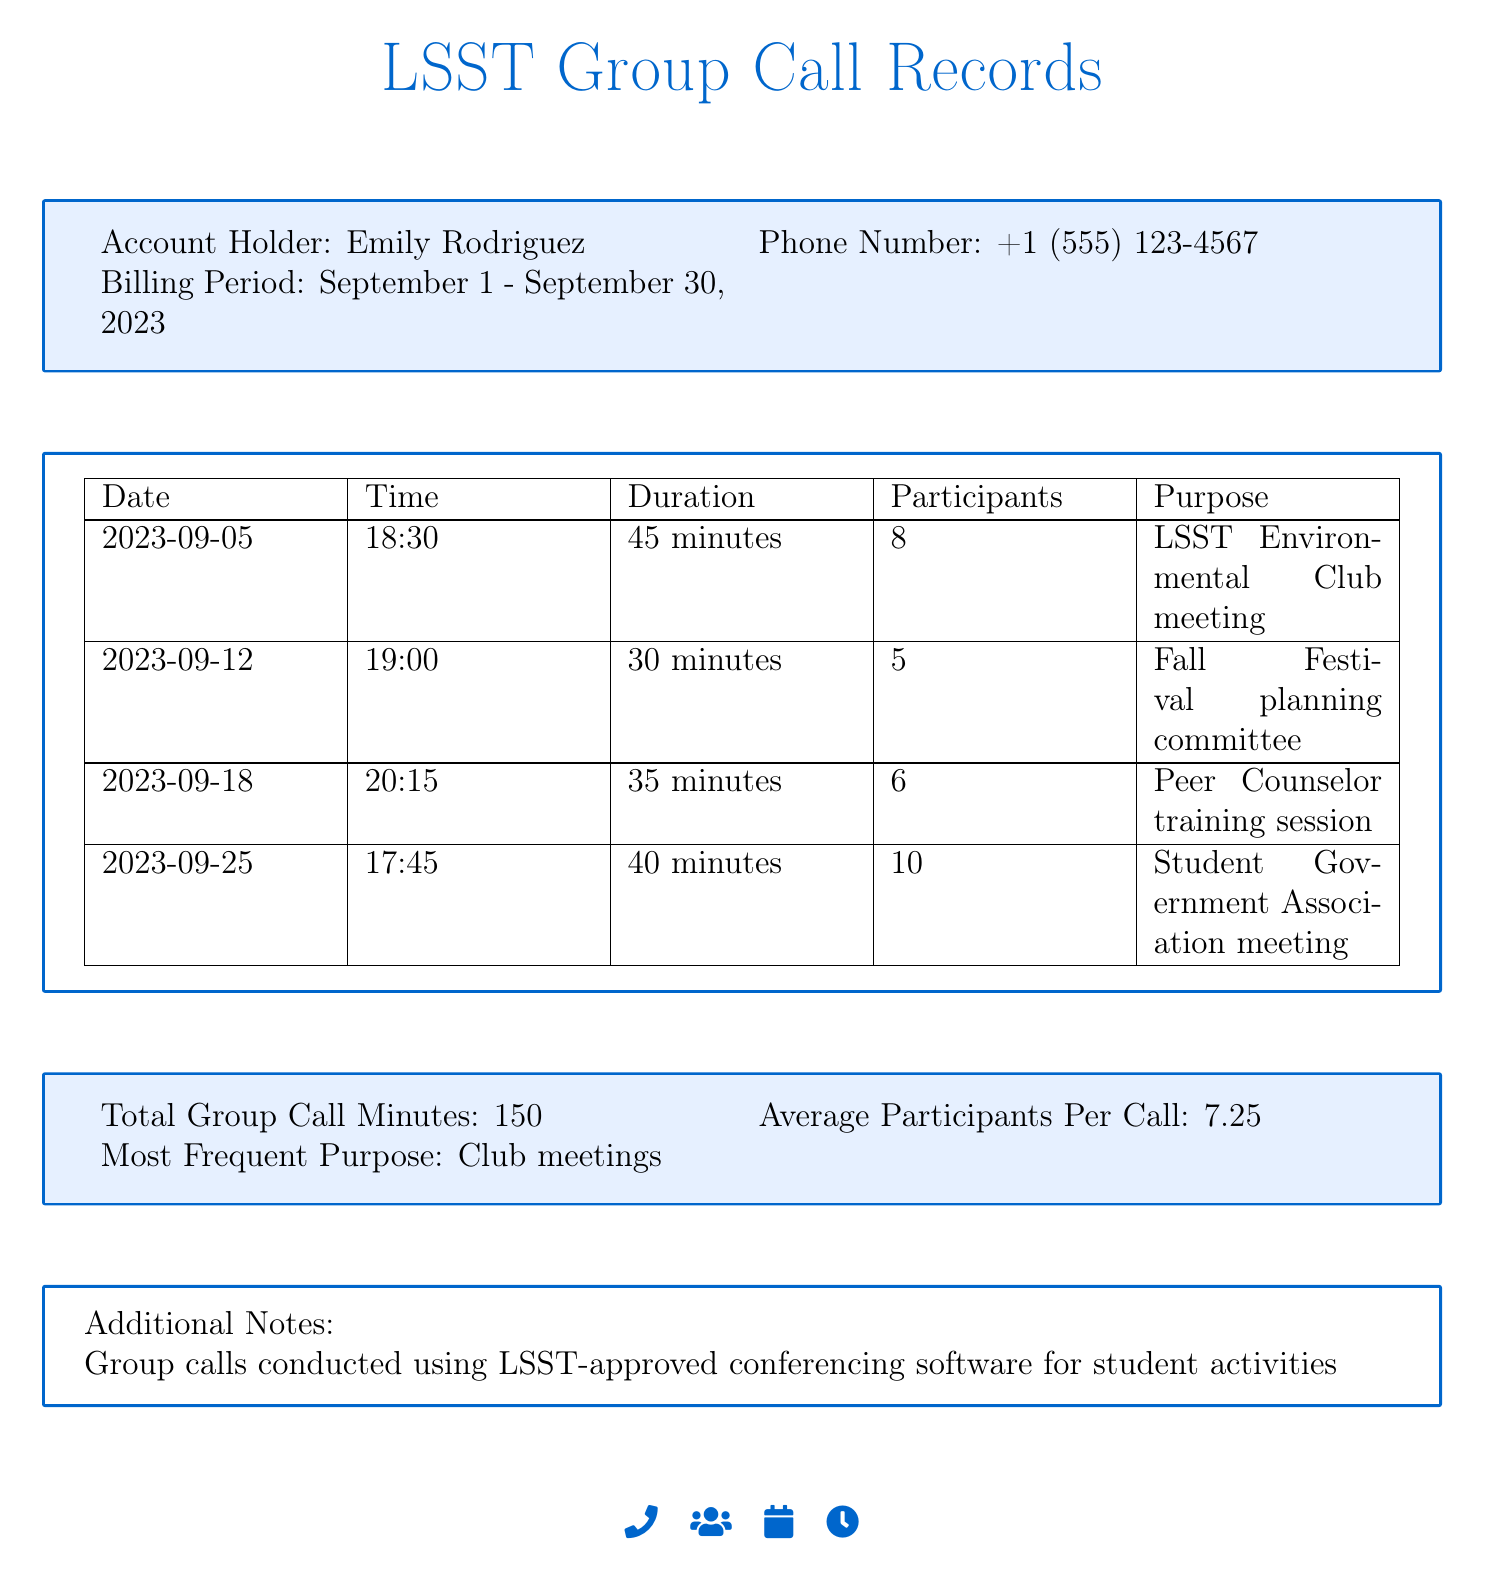what is the account holder's name? The account holder's name is mentioned at the top of the document.
Answer: Emily Rodriguez what is the phone number? The phone number is provided alongside the account holder's name in the document.
Answer: +1 (555) 123-4567 what is the billing period? The billing period is specified in the document for the group call records.
Answer: September 1 - September 30, 2023 how many minutes were used for group calls? The total group call minutes are summarized in the main section of the document.
Answer: 150 what was the most frequent purpose of the calls? This information is detailed at the end of the group call records section.
Answer: Club meetings how many participants were involved in the LSST Environmental Club meeting? The number of participants is listed next to the date and time of the specific call.
Answer: 8 on which date was the Peer Counselor training session held? The date is provided in the table that outlines the call records.
Answer: 2023-09-18 how many minutes did the Fall Festival planning committee call last? The call duration for the specific purpose is listed in the call records table.
Answer: 30 minutes what is the average number of participants per call? The average is calculated and displayed in the summary section of the document.
Answer: 7.25 